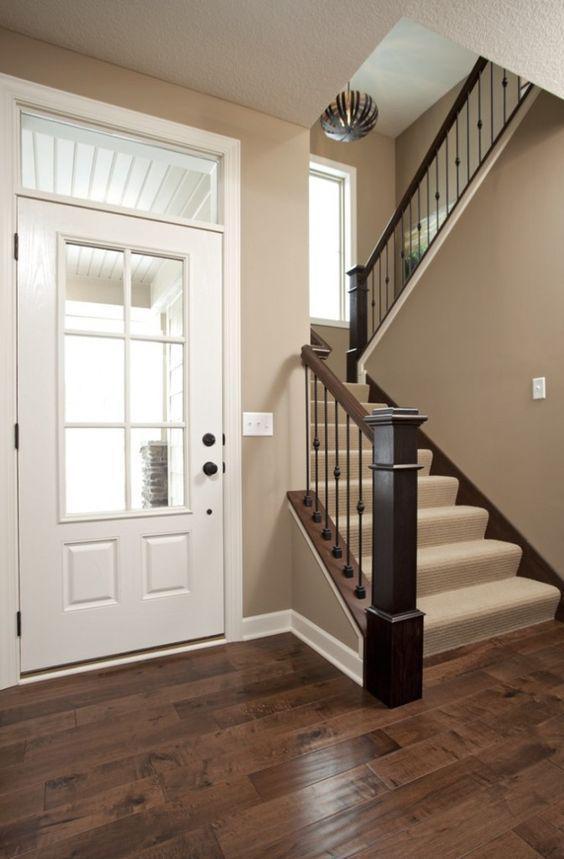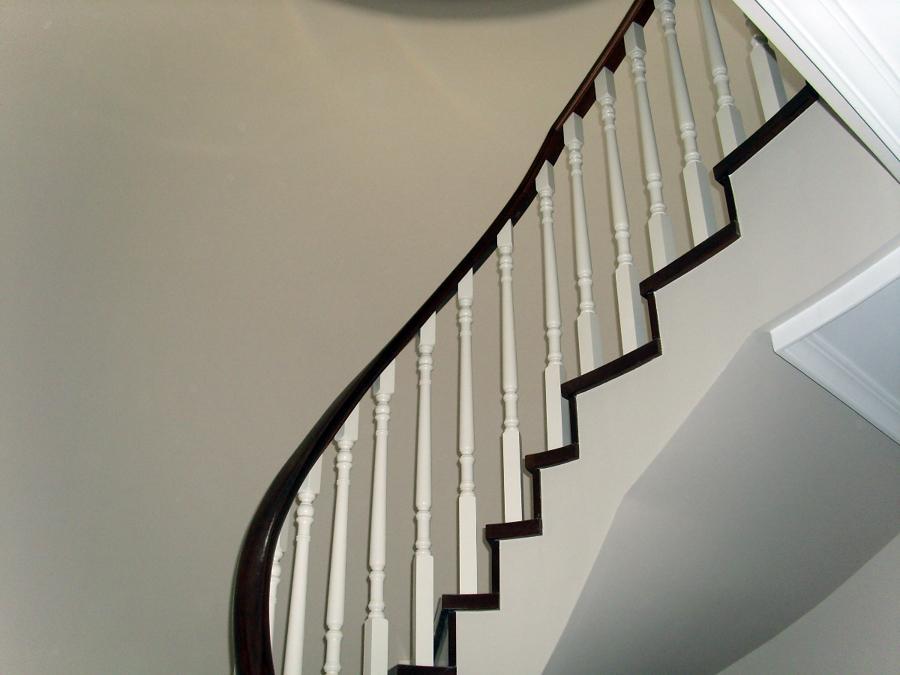The first image is the image on the left, the second image is the image on the right. Given the left and right images, does the statement "The staircase in the image on the right comes down near a striped wall." hold true? Answer yes or no. No. 